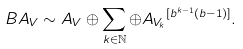<formula> <loc_0><loc_0><loc_500><loc_500>\ B A _ { V } \sim A _ { V } \oplus \sum _ { k \in \mathbb { N } } \oplus { A _ { V _ { k } } } ^ { [ b ^ { k - 1 } ( b - 1 ) ] } .</formula> 